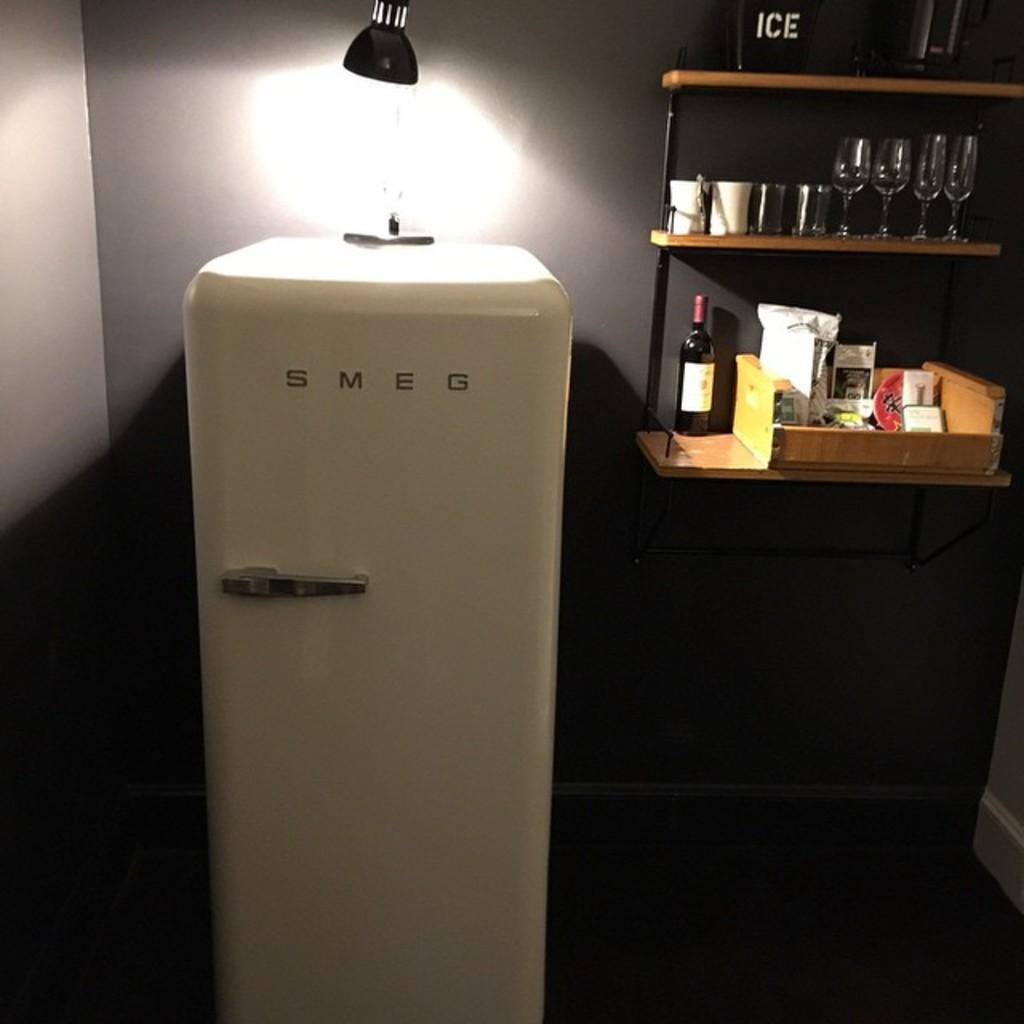<image>
Give a short and clear explanation of the subsequent image. An old fashioned white Smeg fridge with a spotlight shining on the top of it. 